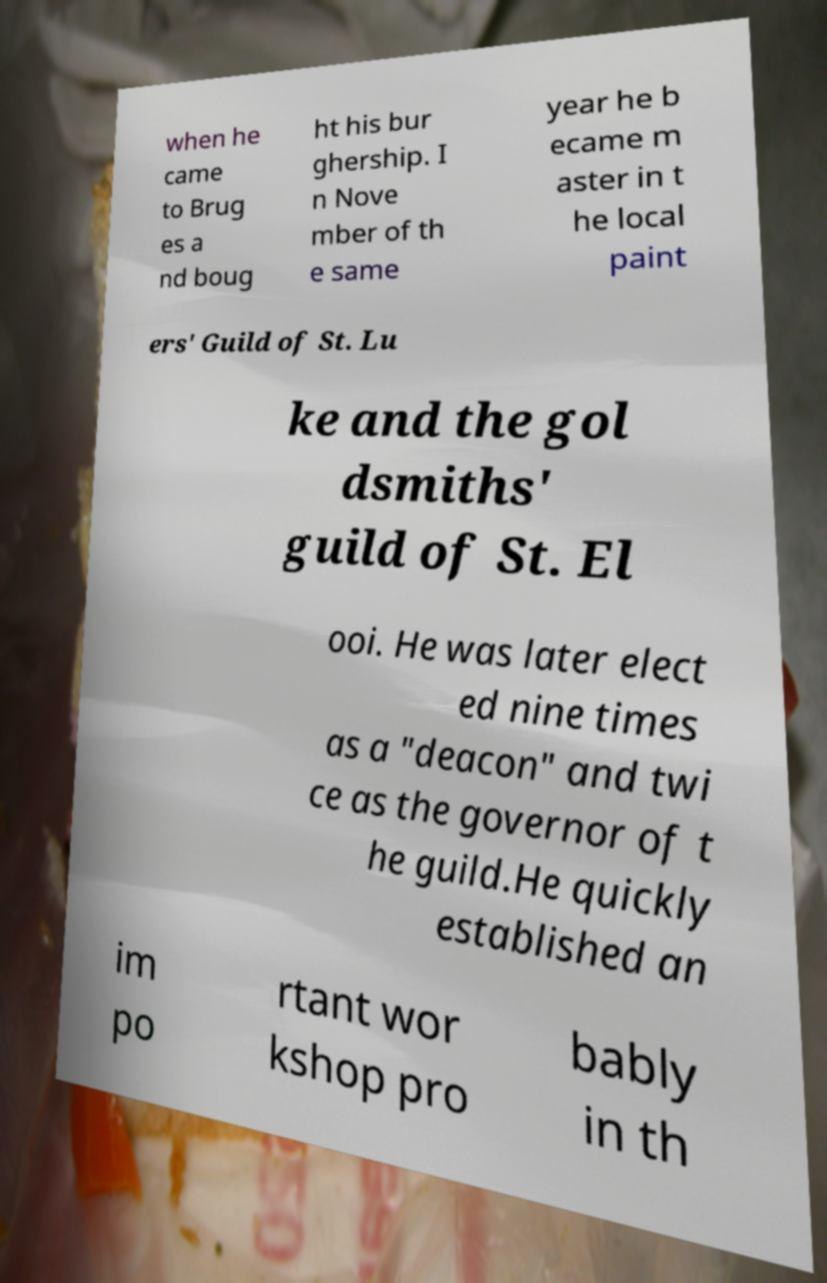For documentation purposes, I need the text within this image transcribed. Could you provide that? when he came to Brug es a nd boug ht his bur ghership. I n Nove mber of th e same year he b ecame m aster in t he local paint ers' Guild of St. Lu ke and the gol dsmiths' guild of St. El ooi. He was later elect ed nine times as a "deacon" and twi ce as the governor of t he guild.He quickly established an im po rtant wor kshop pro bably in th 